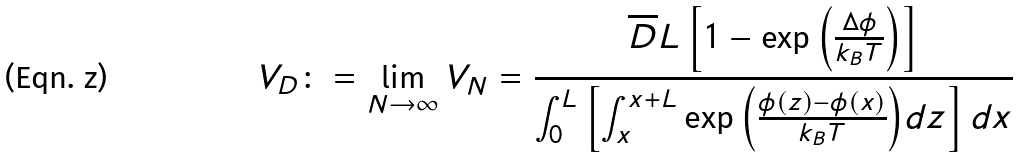<formula> <loc_0><loc_0><loc_500><loc_500>V _ { D } \colon = \lim _ { N \to \infty } V _ { N } = \frac { \overline { D } L \left [ 1 - \exp { \left ( \frac { \Delta \phi } { k _ { B } T } \right ) } \right ] } { \int _ { 0 } ^ { L } \left [ \int _ { x } ^ { x + L } \exp { \left ( \frac { \phi ( z ) - \phi ( x ) } { k _ { B } T } \right ) } d z \right ] d x }</formula> 